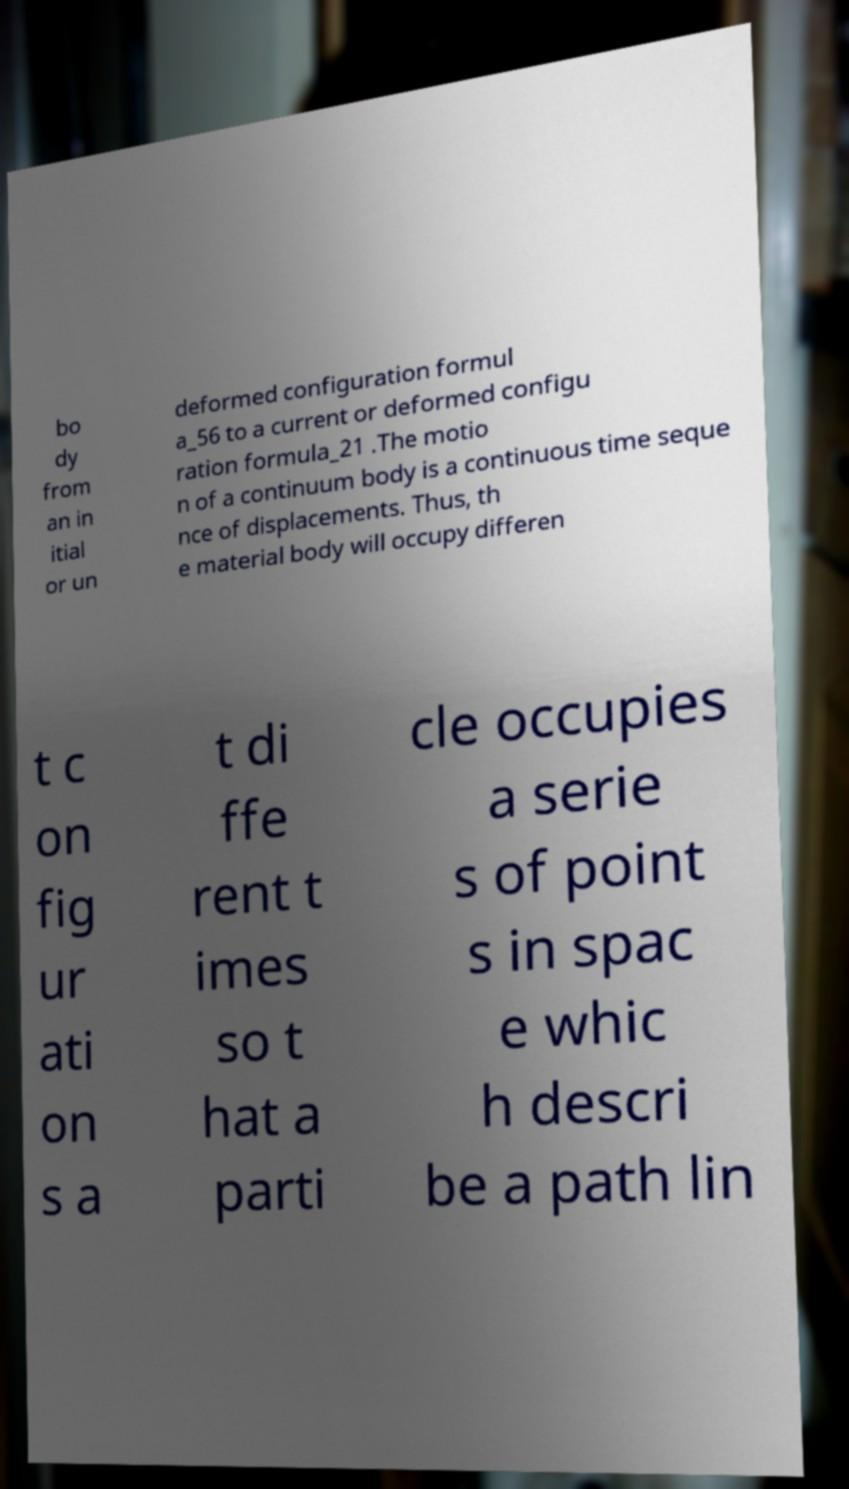For documentation purposes, I need the text within this image transcribed. Could you provide that? bo dy from an in itial or un deformed configuration formul a_56 to a current or deformed configu ration formula_21 .The motio n of a continuum body is a continuous time seque nce of displacements. Thus, th e material body will occupy differen t c on fig ur ati on s a t di ffe rent t imes so t hat a parti cle occupies a serie s of point s in spac e whic h descri be a path lin 